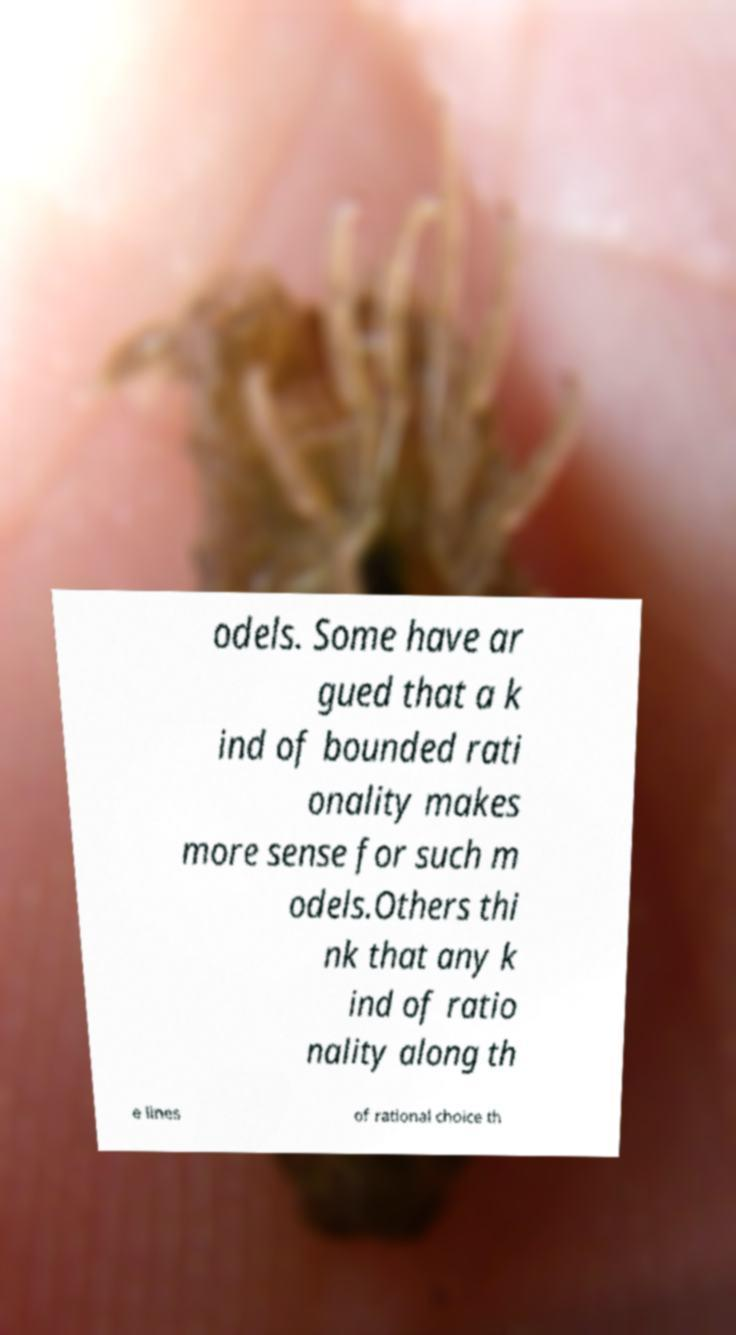Please read and relay the text visible in this image. What does it say? odels. Some have ar gued that a k ind of bounded rati onality makes more sense for such m odels.Others thi nk that any k ind of ratio nality along th e lines of rational choice th 